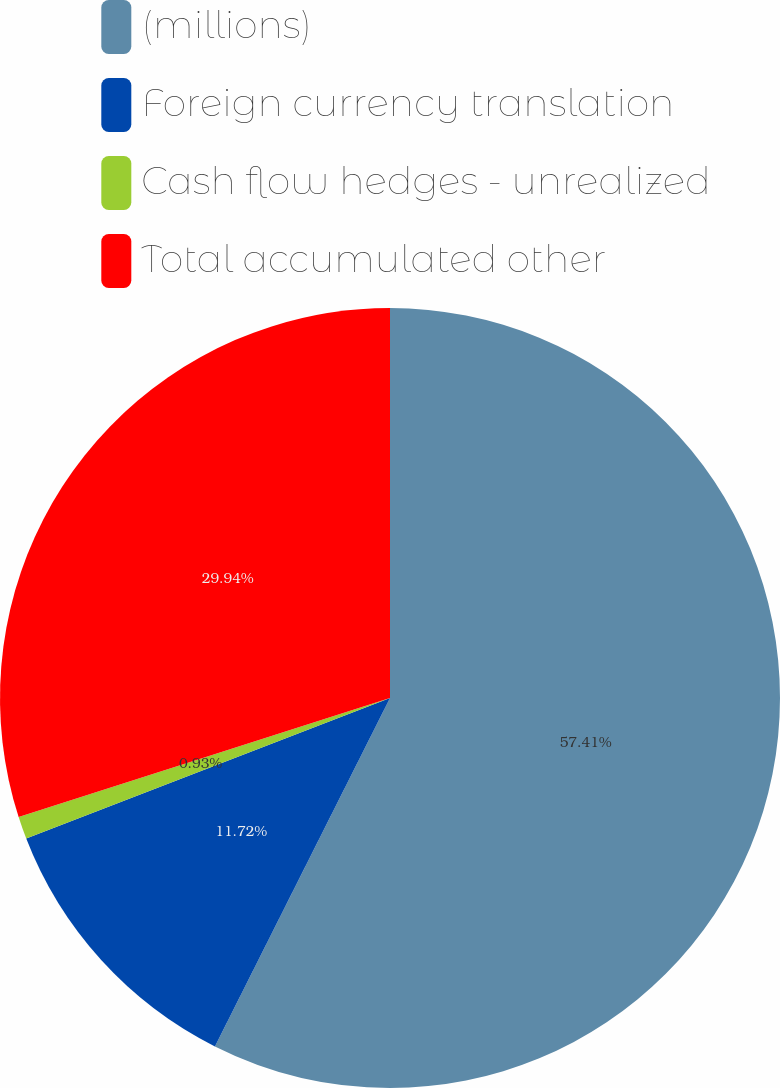<chart> <loc_0><loc_0><loc_500><loc_500><pie_chart><fcel>(millions)<fcel>Foreign currency translation<fcel>Cash flow hedges - unrealized<fcel>Total accumulated other<nl><fcel>57.41%<fcel>11.72%<fcel>0.93%<fcel>29.94%<nl></chart> 